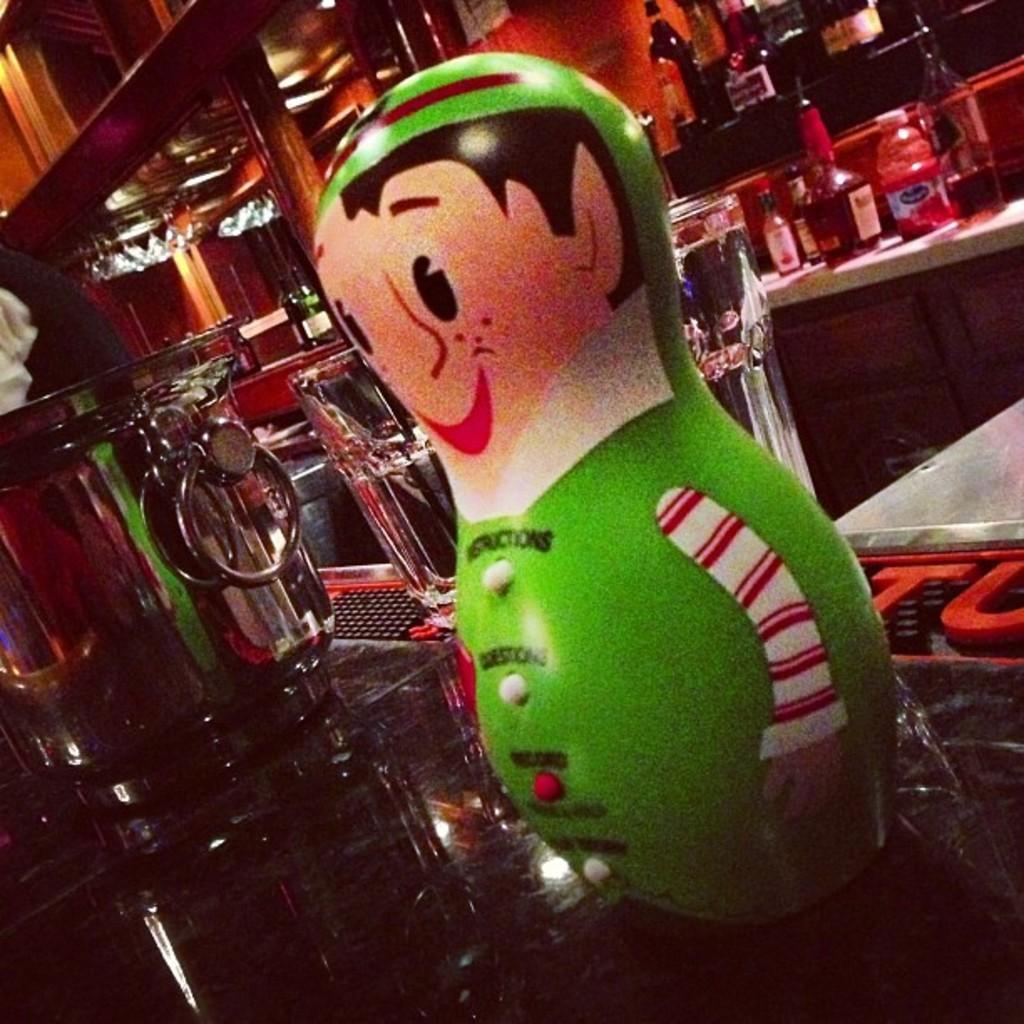How would you summarize this image in a sentence or two? In this picture we can see a toy placed on a table and in background we can see bottles, handle, lights, pillars. 